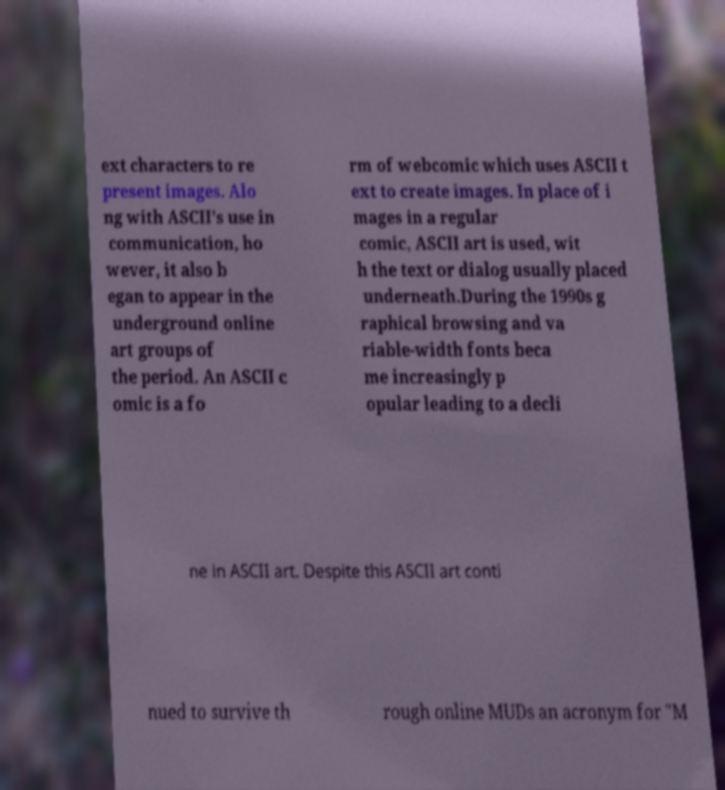For documentation purposes, I need the text within this image transcribed. Could you provide that? ext characters to re present images. Alo ng with ASCII's use in communication, ho wever, it also b egan to appear in the underground online art groups of the period. An ASCII c omic is a fo rm of webcomic which uses ASCII t ext to create images. In place of i mages in a regular comic, ASCII art is used, wit h the text or dialog usually placed underneath.During the 1990s g raphical browsing and va riable-width fonts beca me increasingly p opular leading to a decli ne in ASCII art. Despite this ASCII art conti nued to survive th rough online MUDs an acronym for "M 